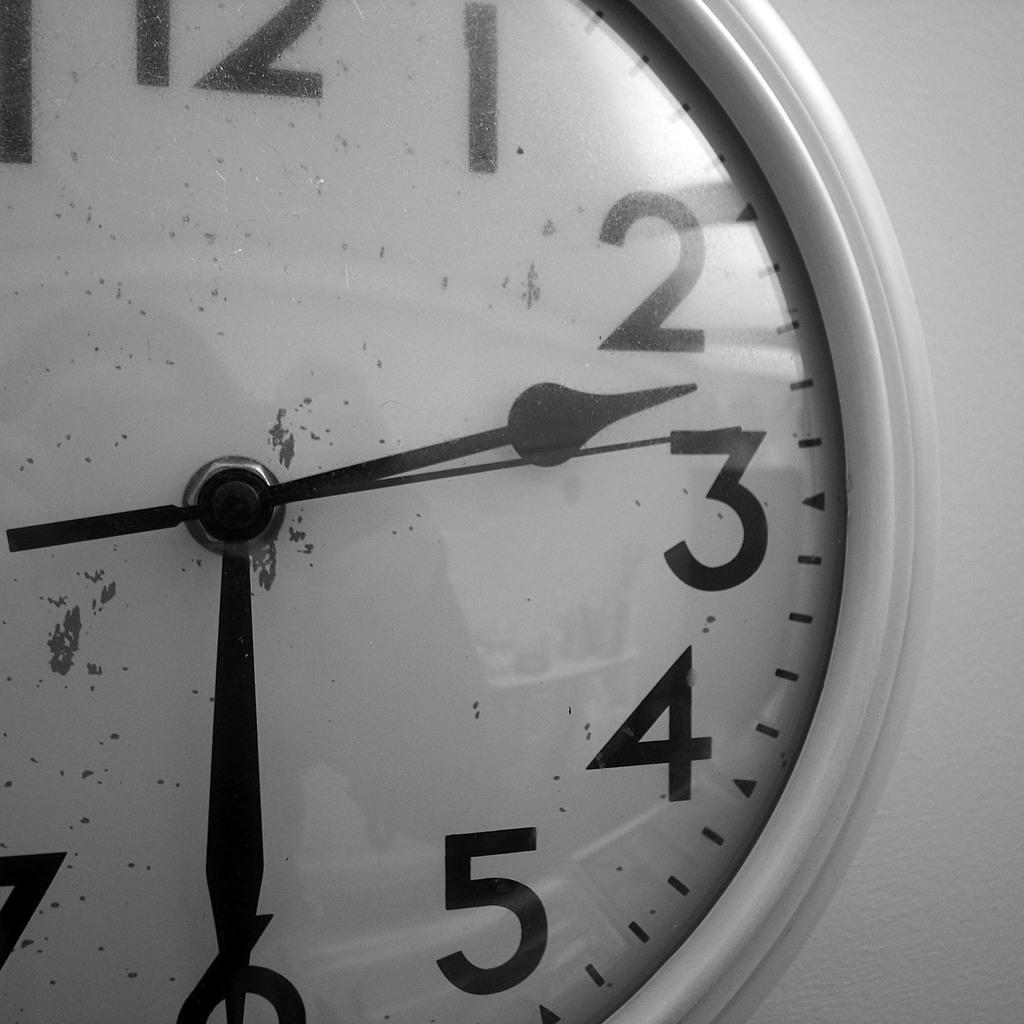What object in the picture indicates the time? There is a clock in the picture that indicates the time. What feature of the clock helps to display the hours? The clock has numbers that help to display the hours. What are the three main components of the clock? The clock has an hour hand, a minute hand, and a second hand. How many ducks are present on the clock in the image? A: There are no ducks present on the clock in the image. What type of digestion process is occurring within the clock in the image? There is no digestion process occurring within the clock in the image, as it is a mechanical object. 